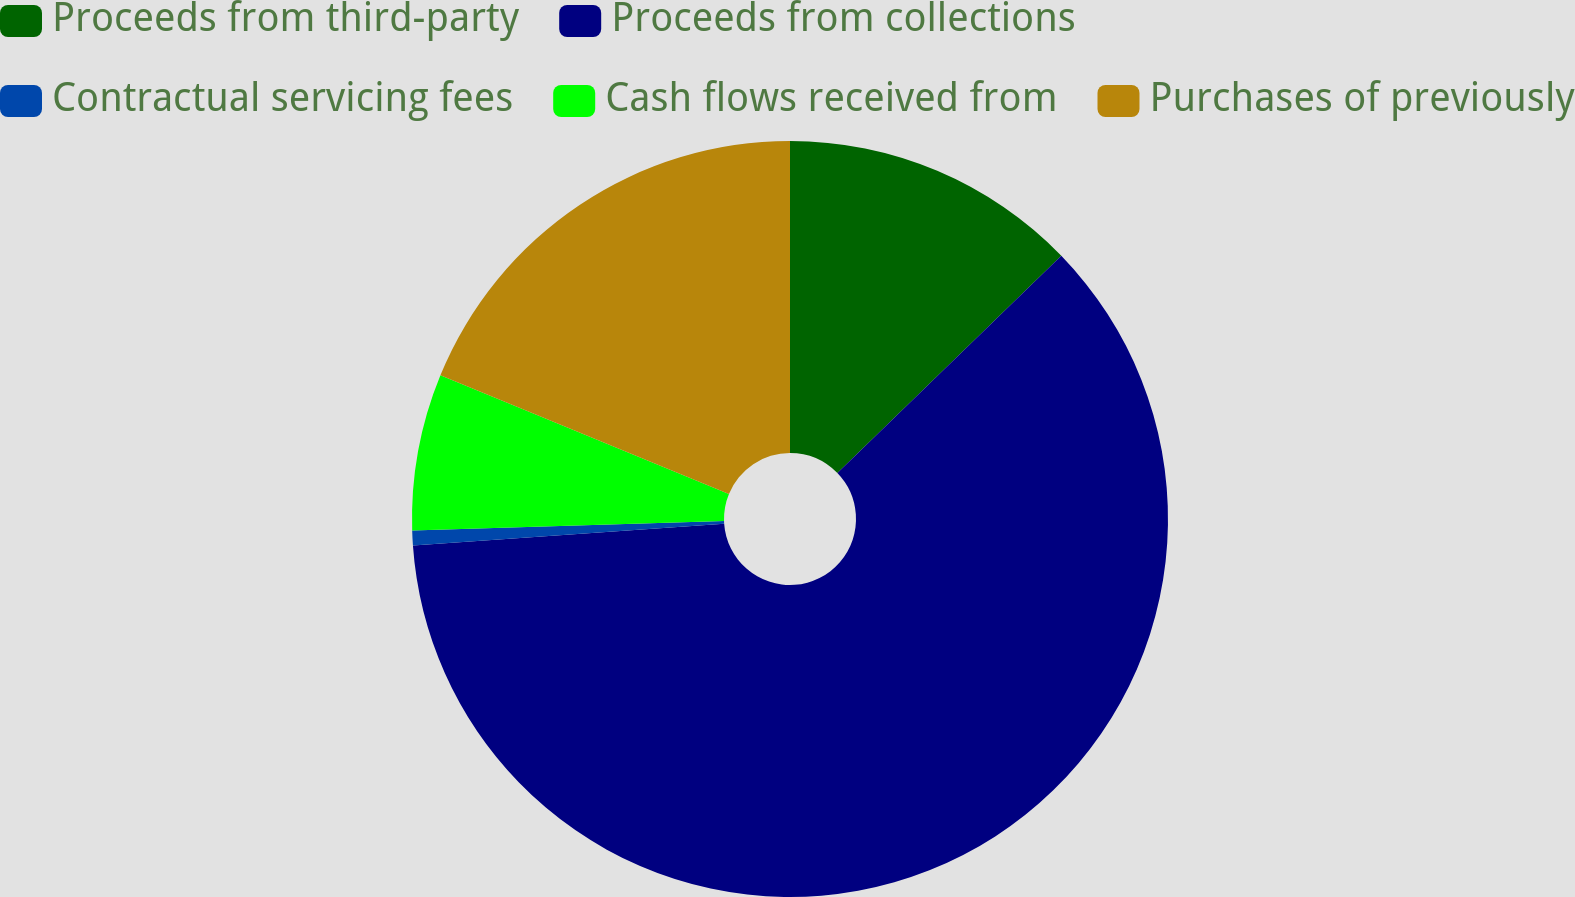Convert chart. <chart><loc_0><loc_0><loc_500><loc_500><pie_chart><fcel>Proceeds from third-party<fcel>Proceeds from collections<fcel>Contractual servicing fees<fcel>Cash flows received from<fcel>Purchases of previously<nl><fcel>12.74%<fcel>61.14%<fcel>0.64%<fcel>6.69%<fcel>18.79%<nl></chart> 